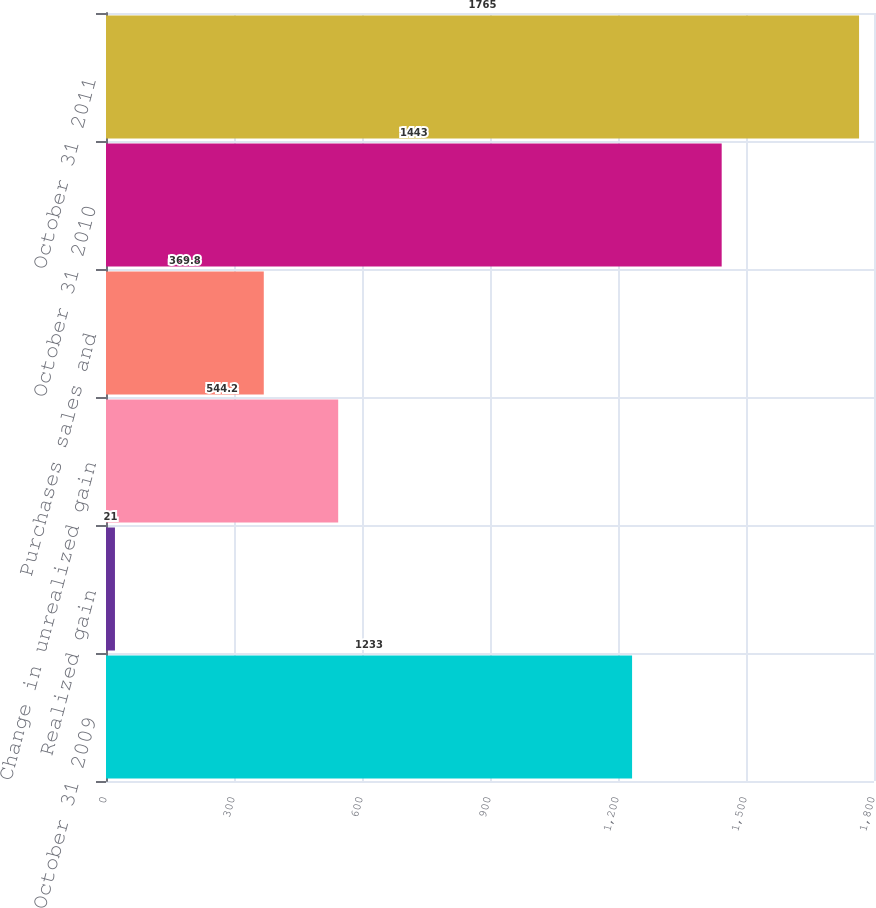<chart> <loc_0><loc_0><loc_500><loc_500><bar_chart><fcel>October 31 2009<fcel>Realized gain<fcel>Change in unrealized gain<fcel>Purchases sales and<fcel>October 31 2010<fcel>October 31 2011<nl><fcel>1233<fcel>21<fcel>544.2<fcel>369.8<fcel>1443<fcel>1765<nl></chart> 